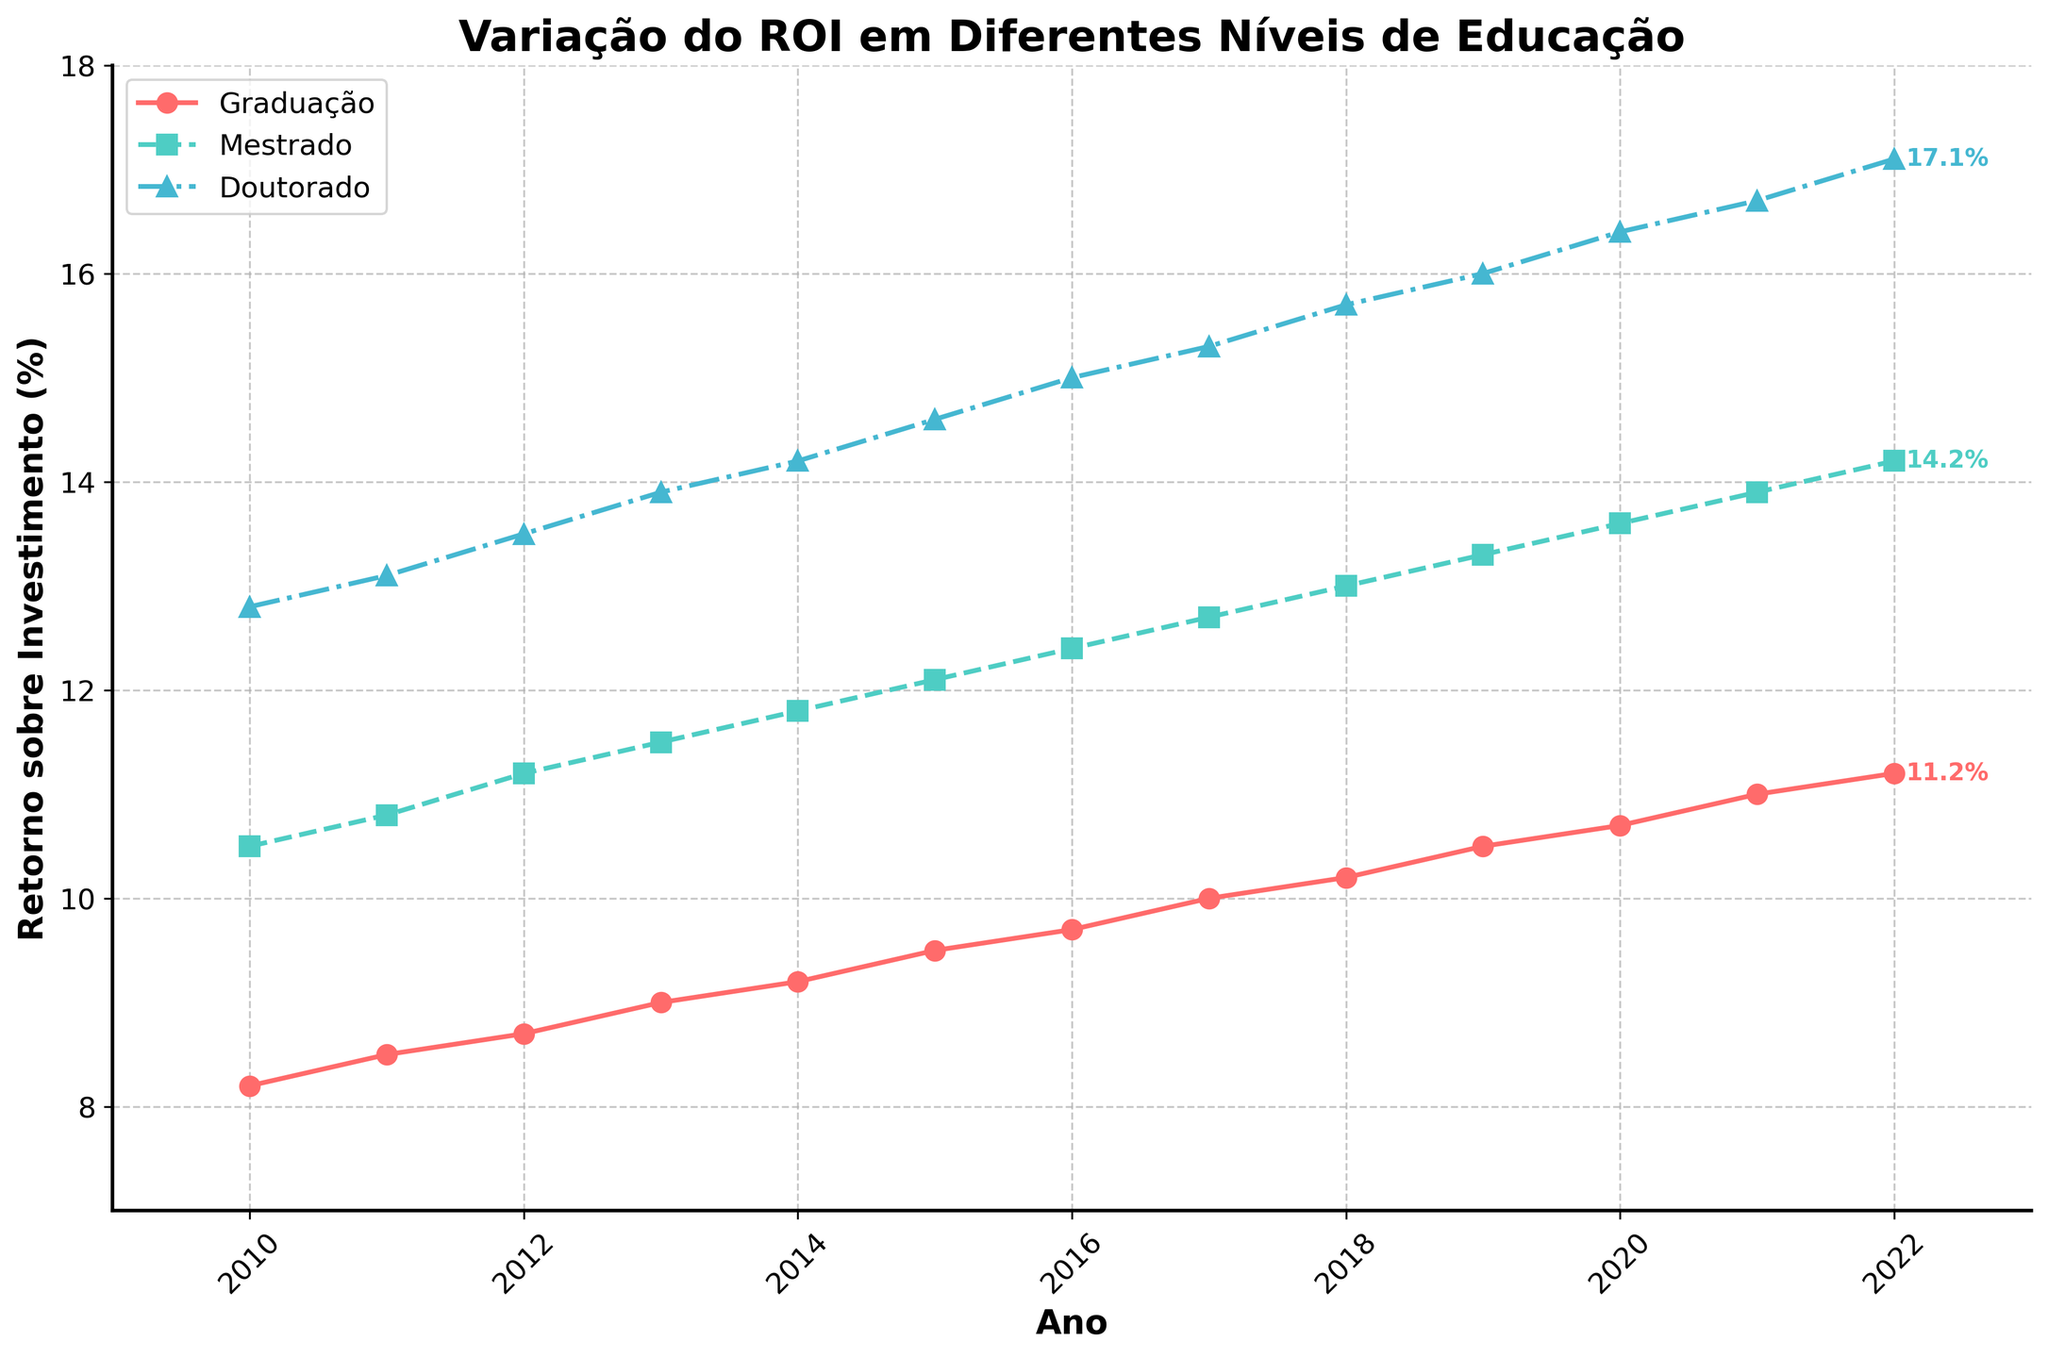Which education level had the highest ROI in 2022? Look at the plotted lines in 2022 and identify the highest value among Graduação, Mestrado, and Doutorado. The highest point corresponds to the highest ROI.
Answer: Doutorado How did the ROI for Graduação change from 2010 to 2022? Identify the ROI values for Graduação in 2010 and 2022 from the plot, then subtract the 2010 value from the 2022 value to find the change. (11.2% - 8.2%)
Answer: Increased by 3.0% Between which two consecutive years did the ROI for Mestrado see the biggest increase? Compare the differences in ROI for each consecutive year for Mestrado by computing each year's change and identifying the maximum.
Answer: 2017 to 2018 Which level of education showed a consistent upward trend without any drop between 2010 and 2022? Observe the plotted lines, checking for any decreases over the years. Identify the line that consistently moves upwards without drops.
Answer: Doutorado In what year did the ROI for Graduação first exceed 10%? Scan the plotted Graduação line to determine the first year it crosses the 10% threshold.
Answer: 2018 What is the overall ROI increase for Doutorado from 2010 to 2022? Identify the ROI values for Doutorado in 2010 and 2022 from the plot. Subtract the 2010 value from the 2022 value to find the increase. (17.1% - 12.8%)
Answer: Increased by 4.3% How does the ROI for Mestrado in 2020 compare to Graduação in 2022? Identify and compare the ROI values for Mestrado in 2020 and Graduação in 2022. (13.6% for Mestrado vs 11.2% for Graduação)
Answer: Higher for Mestrado in 2020 By how much did the ROI for Graduação increase from 2019 to 2020? Identify the ROI values for Graduação in 2019 and 2020 from the plot. Subtract the 2019 value from the 2020 value to find the increase. (10.7% - 10.5%)
Answer: Increased by 0.2% Which education level has the steepest line segment between any two consecutive years, and what is the largest increase observed? Compute the yearly differences for all education levels and identify the largest single increase among them. This can involve checking each line's steepest segment visually. The steepest line segment indicates the largest increase.
Answer: Doutorado, with a 0.4% increase from 2021 to 2022 By what percentage did the ROI for Mestrado change from 2015 to 2022? Identify the ROI values for Mestrado in 2015 and 2022 from the plot. Calculate the percentage change using the formula [(New Value - Old Value) / Old Value] * 100. ([(14.2 - 12.1) / 12.1] * 100)
Answer: 17.4% 